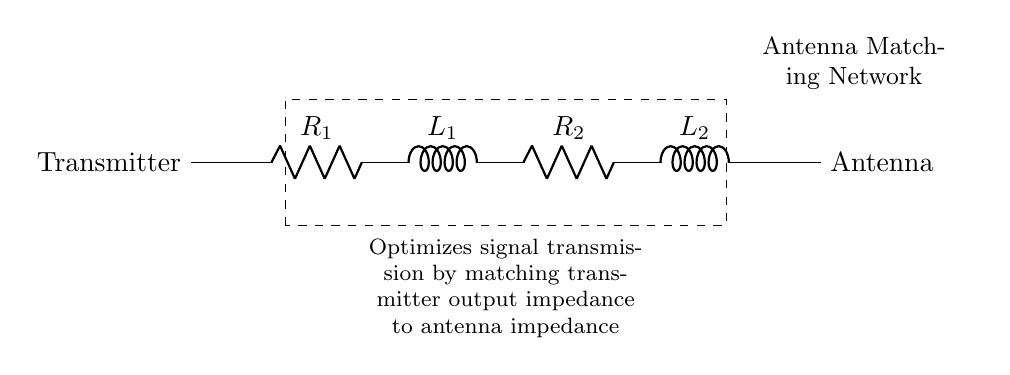What are the components in the circuit? The components include two resistors and two inductors, specifically R1, L1, R2, and L2. This is understood by identifying each labeled component in the circuit diagram.
Answer: Resistors and inductors What function does the matching network serve? The matching network optimizes signal transmission by matching the transmitter output impedance to the antenna impedance. This is indicated in the description provided in the circuit diagram.
Answer: Optimizes signal transmission How many resistors are present in the circuit? There are two resistors, which can be accounted for by counting R1 and R2 in the circuit diagram.
Answer: Two What is the role of L1 in the circuit? L1, as an inductor, is used to adjust the circuit's impedance and can help filter or store energy. It plays a key role in the matching of impedance to optimize signal transmission.
Answer: Adjusts impedance Which components are in series? R1, L1, R2, and L2 are all in series since they are connected one after the other without branching. This can be determined from the layout of the circuit in a single path.
Answer: R1, L1, R2, L2 What are the likely benefits of using inductors in this circuit? Inductors provide benefits such as energy storage, filtering capabilities, and helping to match impedance in a radio frequency application. Their presence allows for better control of signal quality at the antenna.
Answer: Energy storage and filtering 